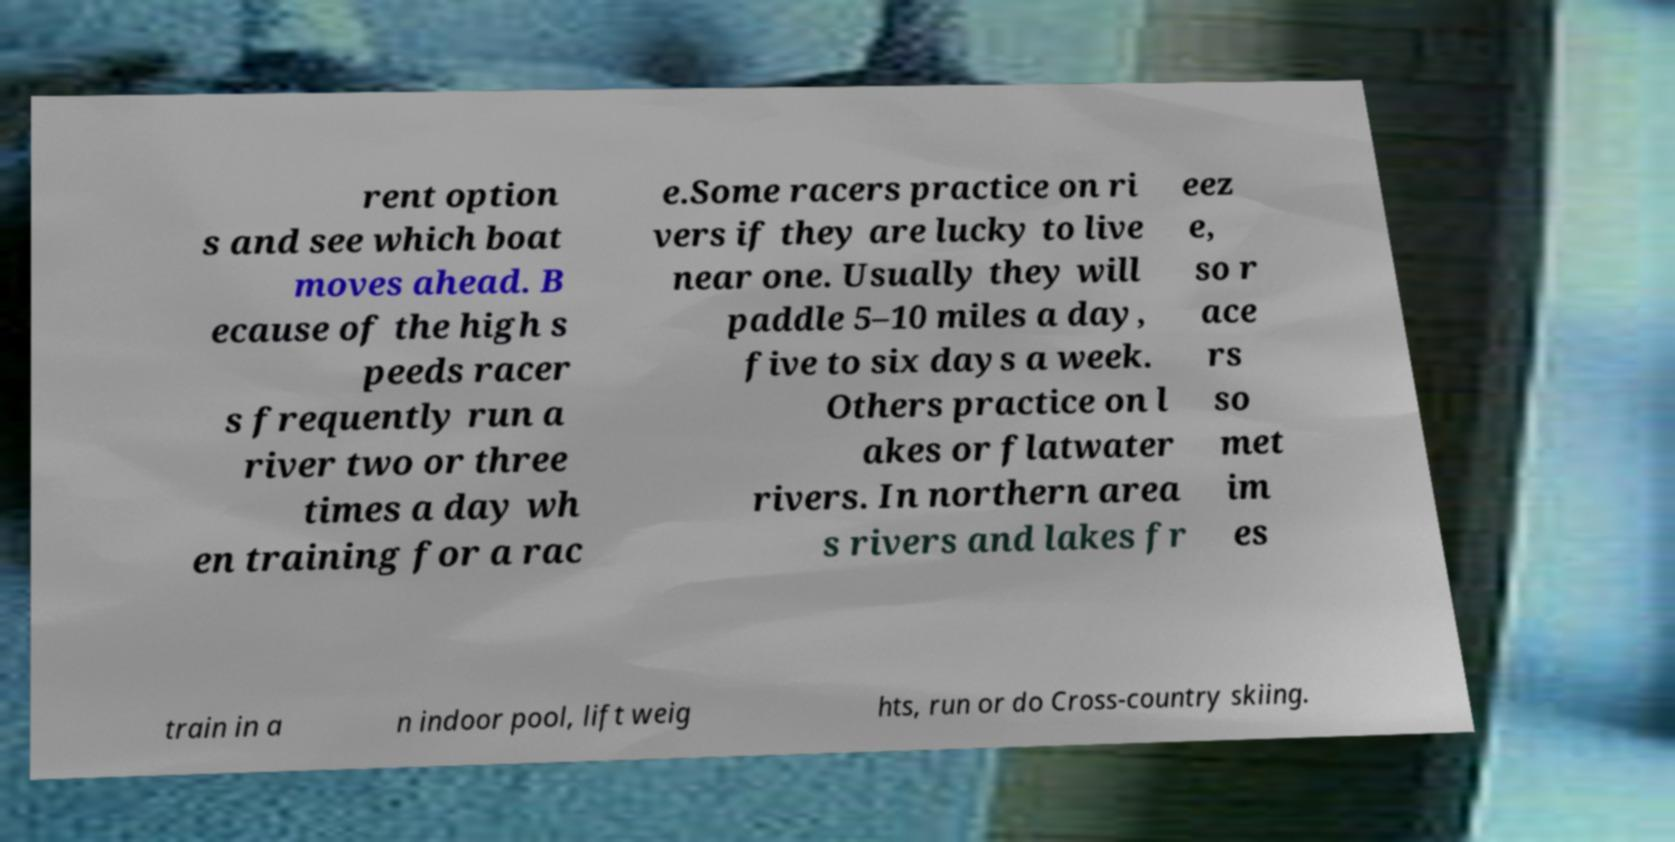Please identify and transcribe the text found in this image. rent option s and see which boat moves ahead. B ecause of the high s peeds racer s frequently run a river two or three times a day wh en training for a rac e.Some racers practice on ri vers if they are lucky to live near one. Usually they will paddle 5–10 miles a day, five to six days a week. Others practice on l akes or flatwater rivers. In northern area s rivers and lakes fr eez e, so r ace rs so met im es train in a n indoor pool, lift weig hts, run or do Cross-country skiing. 